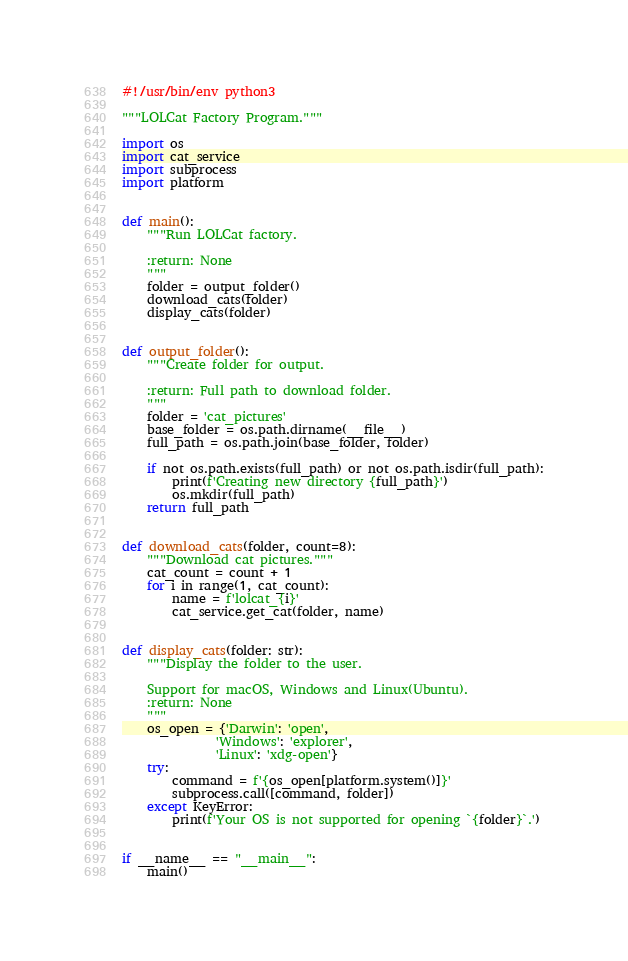<code> <loc_0><loc_0><loc_500><loc_500><_Python_>#!/usr/bin/env python3

"""LOLCat Factory Program."""

import os
import cat_service
import subprocess
import platform


def main():
    """Run LOLCat factory.

    :return: None
    """
    folder = output_folder()
    download_cats(folder)
    display_cats(folder)


def output_folder():
    """Create folder for output.

    :return: Full path to download folder.
    """
    folder = 'cat_pictures'
    base_folder = os.path.dirname(__file__)
    full_path = os.path.join(base_folder, folder)

    if not os.path.exists(full_path) or not os.path.isdir(full_path):
        print(f'Creating new directory {full_path}')
        os.mkdir(full_path)
    return full_path


def download_cats(folder, count=8):
    """Download cat pictures."""
    cat_count = count + 1
    for i in range(1, cat_count):
        name = f'lolcat_{i}'
        cat_service.get_cat(folder, name)


def display_cats(folder: str):
    """Display the folder to the user.

    Support for macOS, Windows and Linux(Ubuntu).
    :return: None
    """
    os_open = {'Darwin': 'open',
               'Windows': 'explorer',
               'Linux': 'xdg-open'}
    try:
        command = f'{os_open[platform.system()]}'
        subprocess.call([command, folder])
    except KeyError:
        print(f'Your OS is not supported for opening `{folder}`.')


if __name__ == "__main__":
    main()
</code> 